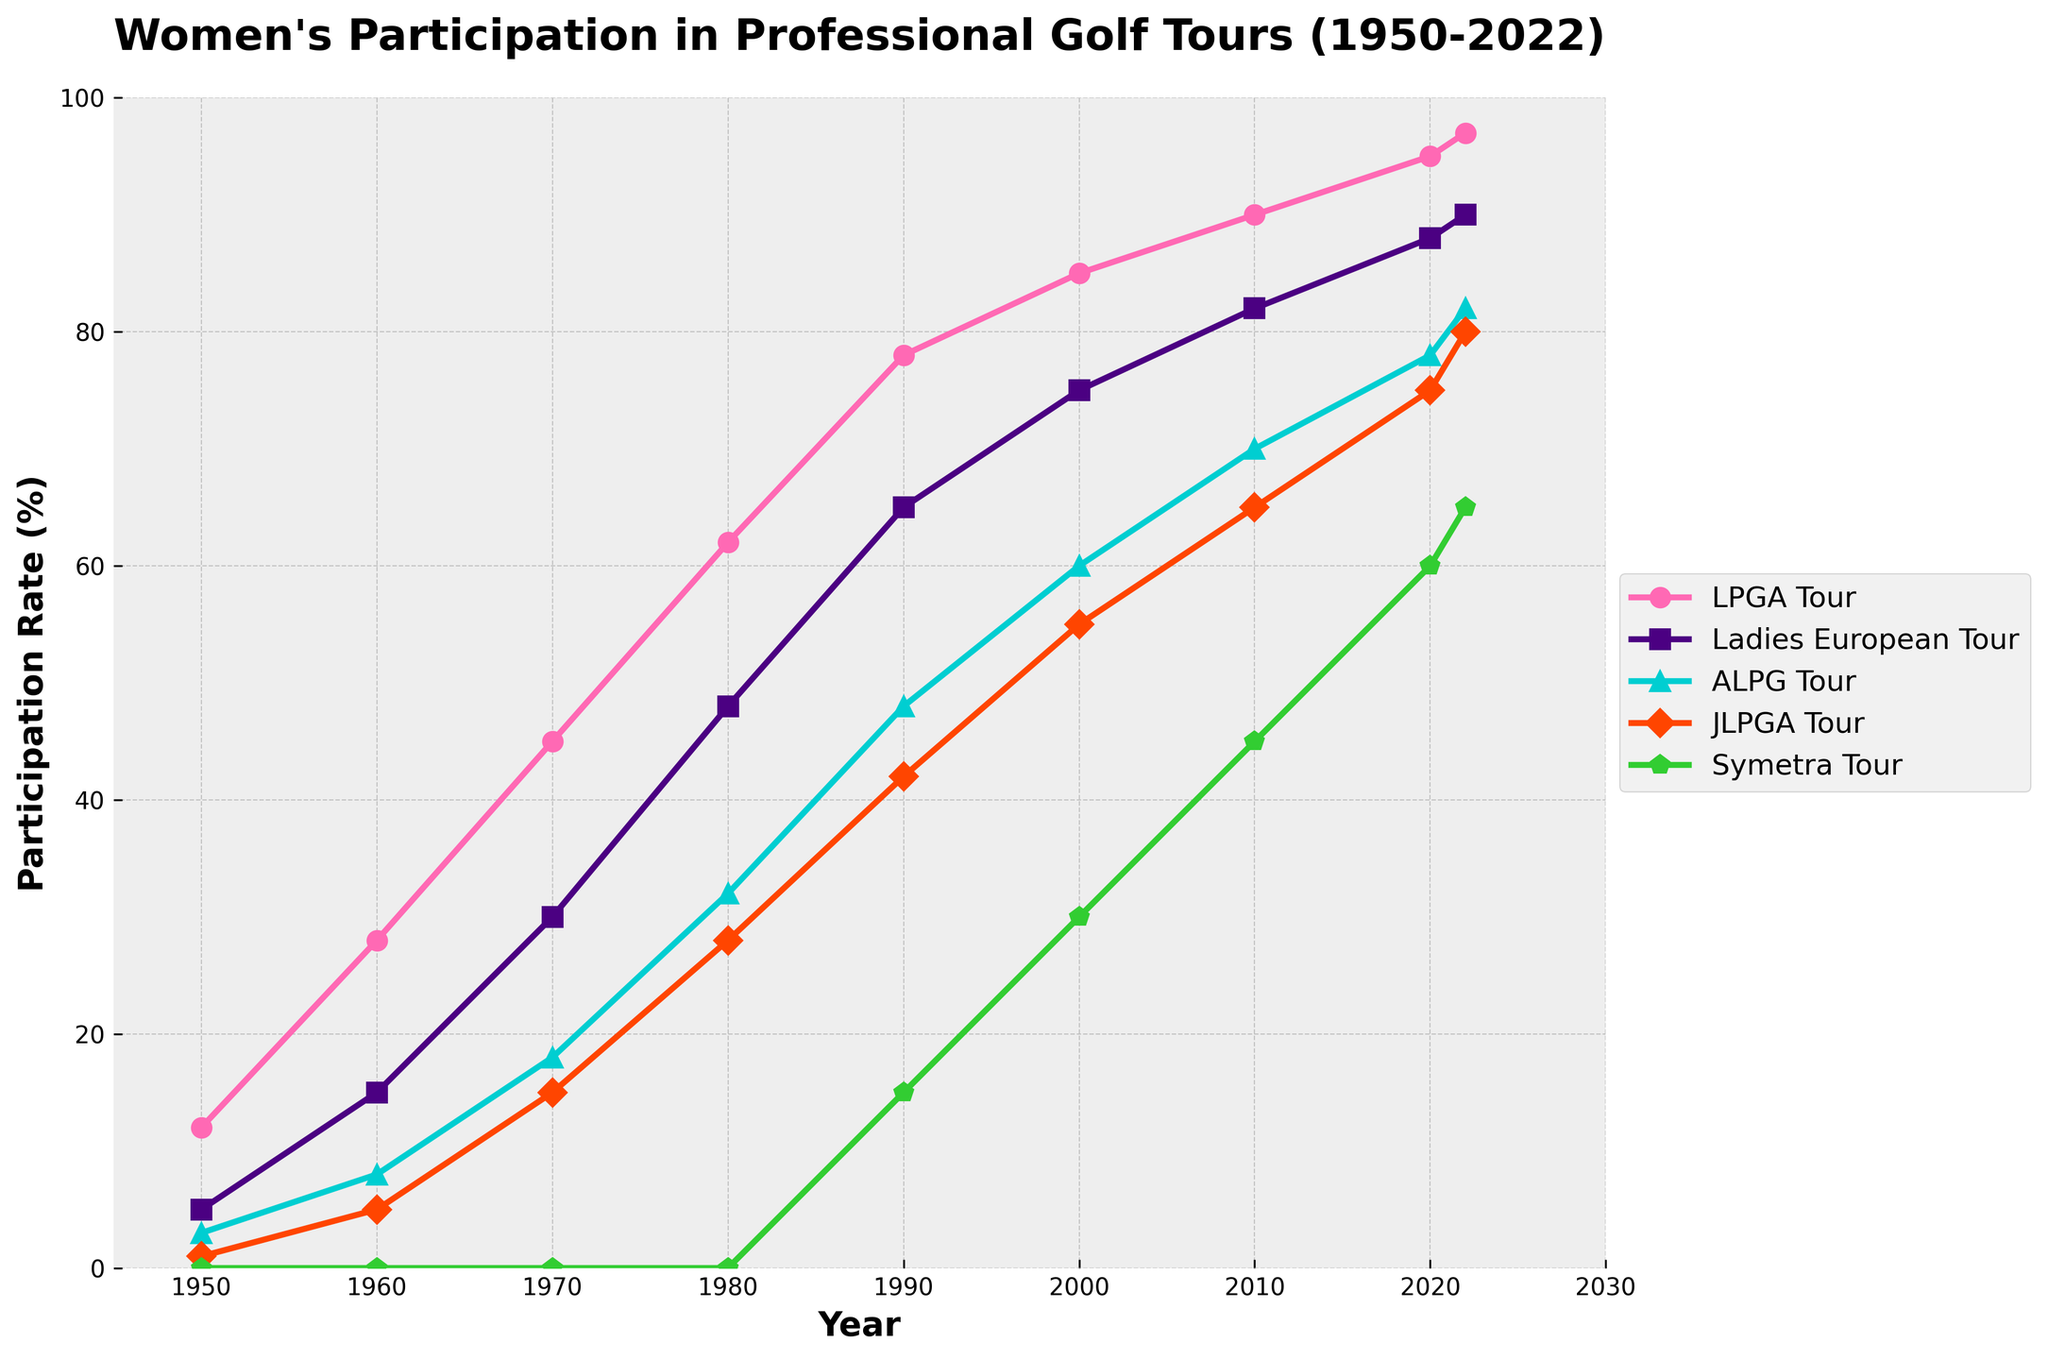What's the trend in women's participation in the LPGA Tour from 1950 to 2022? To determine the trend, observe the line for the LPGA Tour from 1950 to 2022. The line consistently increases, indicating a positive trend in participation rates.
Answer: Increasing trend In which decade did the Ladies European Tour see the highest increase in participation rates? Look at the differences between the participation rates for the Ladies European Tour across each decade. The steepest increase is seen from 1970 (30%) to 1980 (48%), which is an 18% rise.
Answer: 1970s By how much did the JLPGA Tour's participation rate increase from 2000 to 2020? Check the participation rates for the JLPGA Tour in 2000 (55%) and 2020 (75%). Calculate the difference by subtracting the earlier rate from the later rate: 75% - 55% = 20%.
Answer: 20% Compare the participation rates of the ALPG Tour and Symetra Tour in 2010. Which tour had a higher rate and by how much? Refer to the rates in 2010 for both tours: ALPG Tour (70%) and Symetra Tour (45%). Subtract the lower rate (Symetra) from the higher rate (ALPG): 70% - 45% = 25%.
Answer: ALPG Tour by 25% Which tour had the highest participation rate in 1950? Observe the y-values of all the lines in 1950. The LPGA Tour has the highest rate at 12%.
Answer: LPGA Tour How does the increase in participation for the Symetra Tour from 1990 to 2000 compare to the increase from 2000 to 2010? Calculate the changes for each period: 1990 (15%) to 2000 (30%) is 15%, and 2000 (30%) to 2010 (45%) is also 15%. Both periods show an increase of 15%.
Answer: Equal increase of 15% in both periods In 2022, what is the difference between the participation rates of the highest and the lowest tour? Identify the highest (LPGA Tour at 97%) and the lowest (Symetra Tour at 65%) rates in 2022. Subtract the lowest from the highest: 97% - 65% = 32%.
Answer: 32% What was the average participation rate of the Ladies European Tour in the decades 1970, 1980, and 1990? Add the rates for 1970 (30%), 1980 (48%), and 1990 (65%), then divide by 3: (30 + 48 + 65) / 3 = 47.67%.
Answer: 47.67% Between 1950 and 1960, which tour had the greatest percentage increase in participation, and what is the percentage? Compare the increases for each tour: LPGA (16%), European (10%), ALPG (5%), JLPGA (4%), and Symetra (0%). LPGA has the highest increase.
Answer: LPGA Tour, 16% What visual elements are used to differentiate the lines for each tour in the chart? Observe the characteristics of the lines: they use different colors and markers (e.g., circles, squares, triangles, diamonds, pentagons) to represent each tour.
Answer: Different colors and markers 